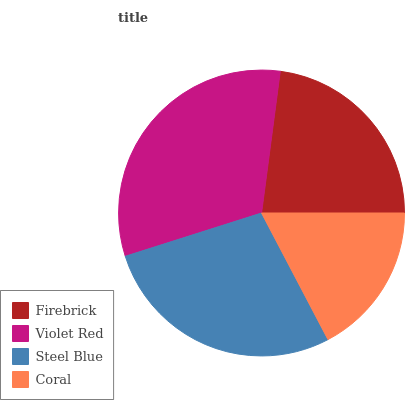Is Coral the minimum?
Answer yes or no. Yes. Is Violet Red the maximum?
Answer yes or no. Yes. Is Steel Blue the minimum?
Answer yes or no. No. Is Steel Blue the maximum?
Answer yes or no. No. Is Violet Red greater than Steel Blue?
Answer yes or no. Yes. Is Steel Blue less than Violet Red?
Answer yes or no. Yes. Is Steel Blue greater than Violet Red?
Answer yes or no. No. Is Violet Red less than Steel Blue?
Answer yes or no. No. Is Steel Blue the high median?
Answer yes or no. Yes. Is Firebrick the low median?
Answer yes or no. Yes. Is Firebrick the high median?
Answer yes or no. No. Is Coral the low median?
Answer yes or no. No. 